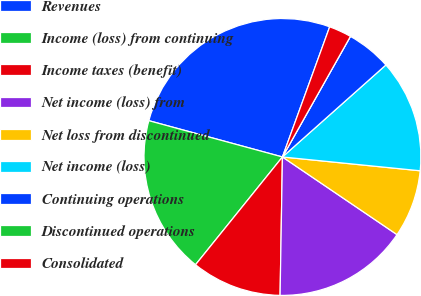Convert chart to OTSL. <chart><loc_0><loc_0><loc_500><loc_500><pie_chart><fcel>Revenues<fcel>Income (loss) from continuing<fcel>Income taxes (benefit)<fcel>Net income (loss) from<fcel>Net loss from discontinued<fcel>Net income (loss)<fcel>Continuing operations<fcel>Discontinued operations<fcel>Consolidated<nl><fcel>26.32%<fcel>18.42%<fcel>10.53%<fcel>15.79%<fcel>7.89%<fcel>13.16%<fcel>5.26%<fcel>0.0%<fcel>2.63%<nl></chart> 